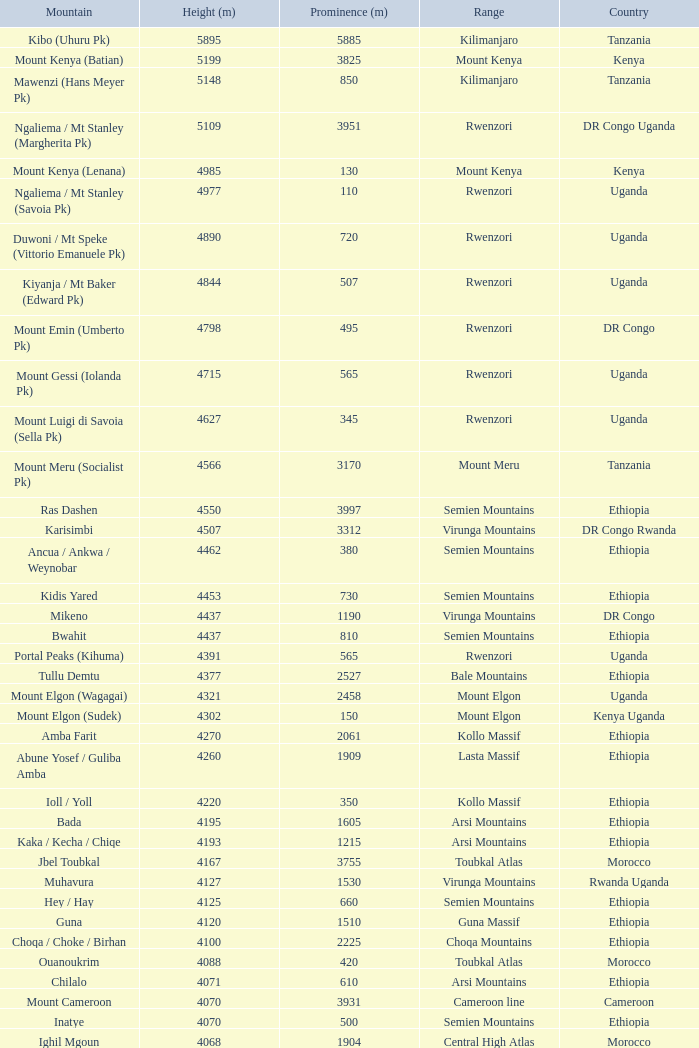Which nation boasts a mountain exceeding 4100 meters in height, belonging to the arsi mountain range, and known as bada? Ethiopia. 